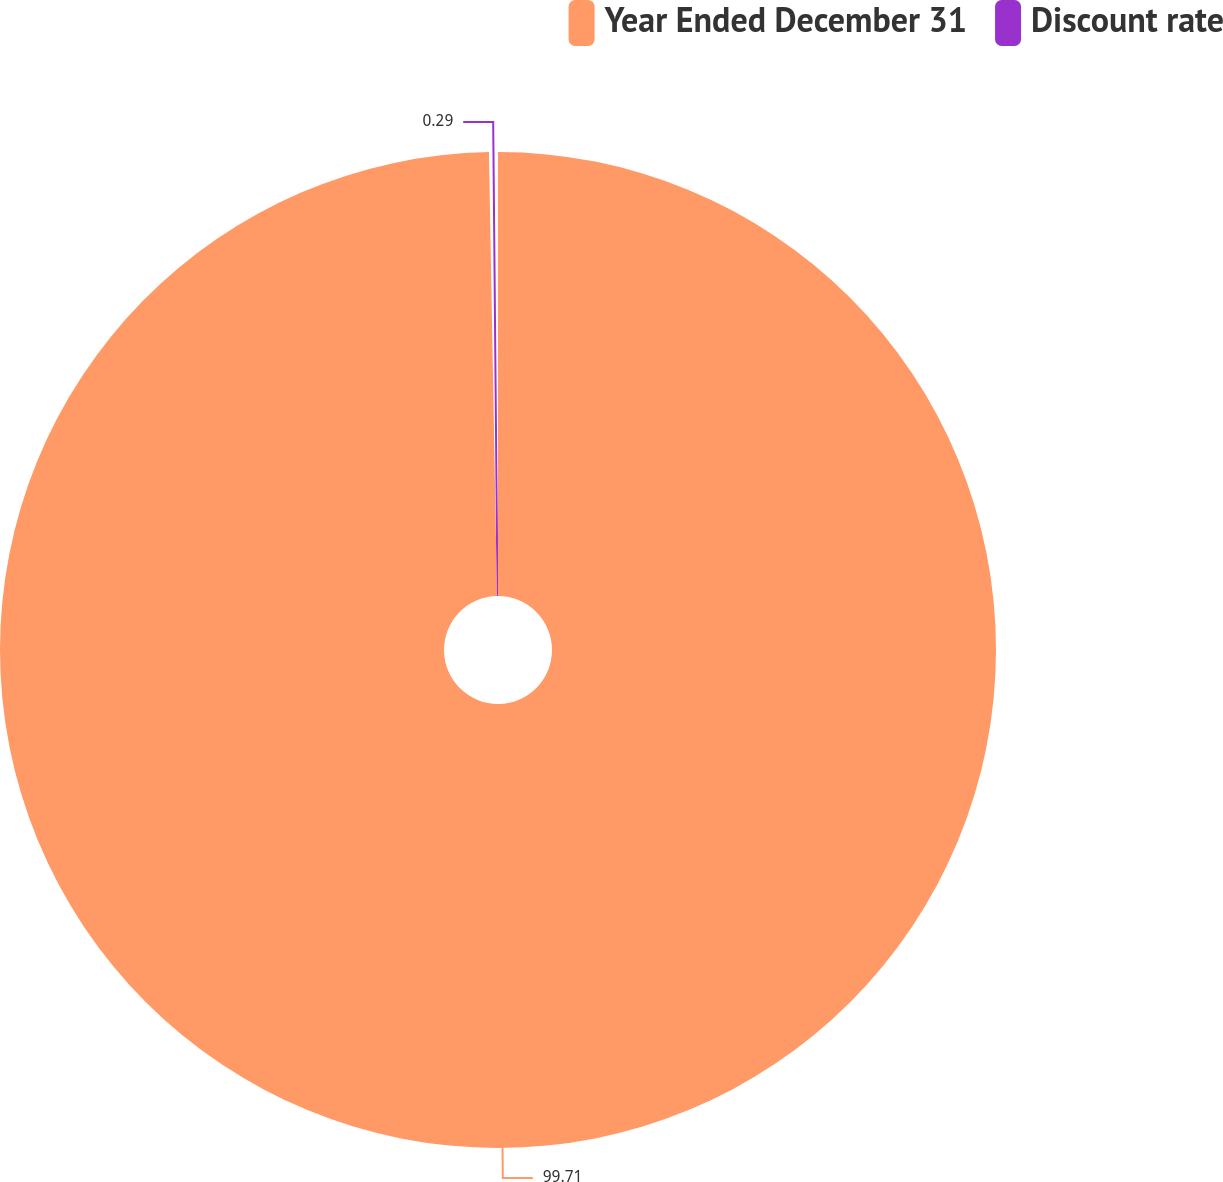<chart> <loc_0><loc_0><loc_500><loc_500><pie_chart><fcel>Year Ended December 31<fcel>Discount rate<nl><fcel>99.71%<fcel>0.29%<nl></chart> 